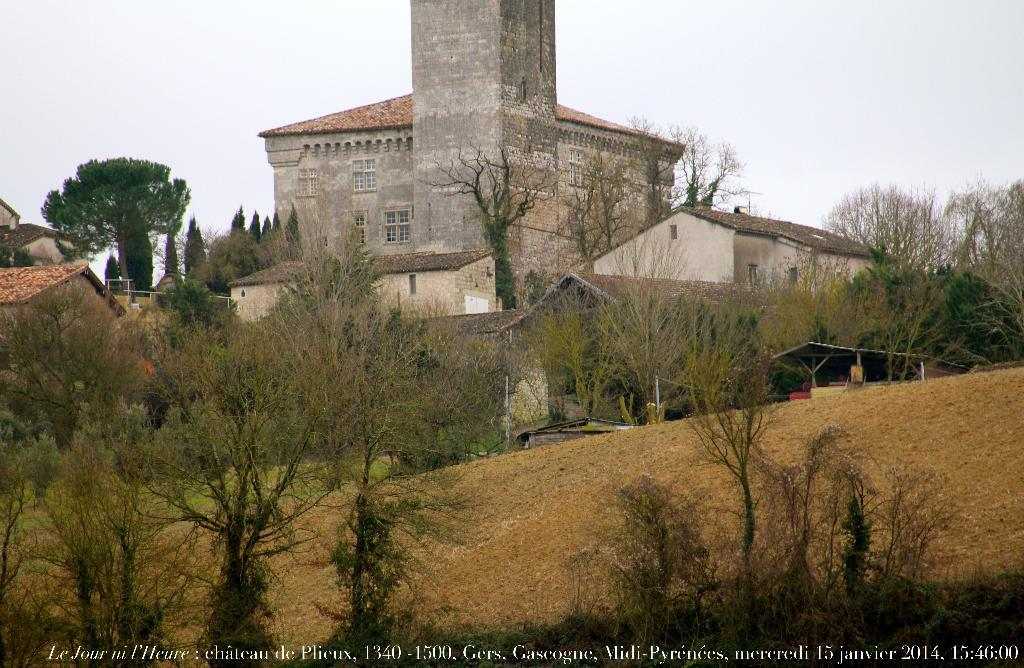What type of structures can be seen in the image? There are buildings in the image. What natural elements are present in the image? There are trees in the image. What is the terrain feature in the foreground of the image? There is a hill in the foreground of the image. What is visible at the top of the image? The sky is visible at the top of the image. Is there any text present in the image? Yes, there is text on the image. Where is the group of part-time farmers working in the image? There is no group of part-time farmers present in the image. What type of field can be seen in the image? There is no field present in the image; it features buildings, trees, a hill, and the sky. 